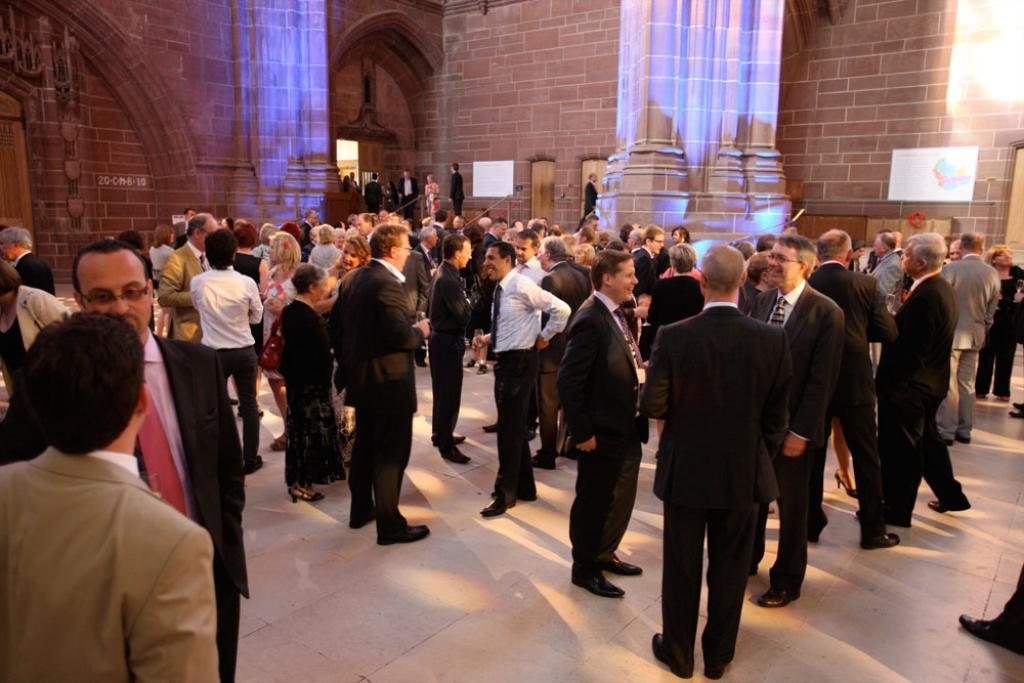How many people can be seen in the image? There are many people in the image. What structures are present in the image? There are pillories in the image. What type of background can be seen in the image? There are walls visible in the image. What type of farming equipment can be seen in the image? There is no farming equipment present in the image. How many people are resting in the image? The image does not show people resting; it shows many people in a different context. 